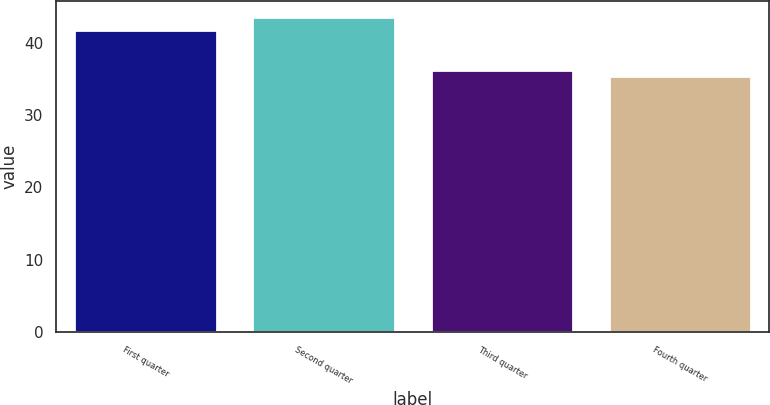Convert chart. <chart><loc_0><loc_0><loc_500><loc_500><bar_chart><fcel>First quarter<fcel>Second quarter<fcel>Third quarter<fcel>Fourth quarter<nl><fcel>41.8<fcel>43.6<fcel>36.22<fcel>35.4<nl></chart> 